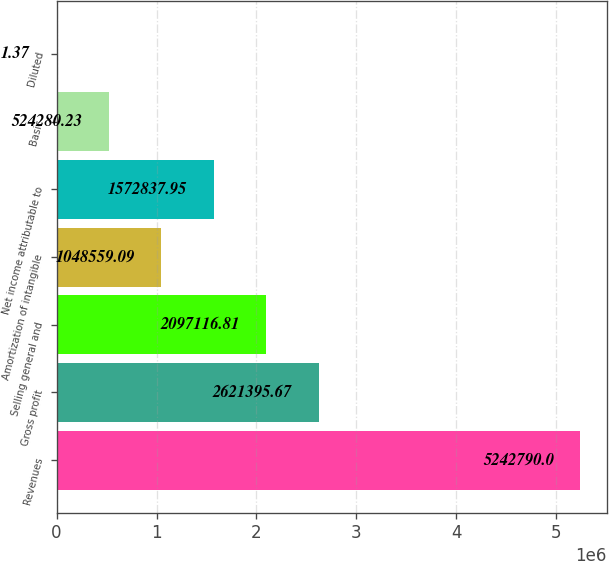Convert chart. <chart><loc_0><loc_0><loc_500><loc_500><bar_chart><fcel>Revenues<fcel>Gross profit<fcel>Selling general and<fcel>Amortization of intangible<fcel>Net income attributable to<fcel>Basic<fcel>Diluted<nl><fcel>5.24279e+06<fcel>2.6214e+06<fcel>2.09712e+06<fcel>1.04856e+06<fcel>1.57284e+06<fcel>524280<fcel>1.37<nl></chart> 